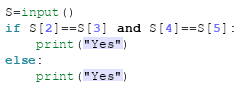<code> <loc_0><loc_0><loc_500><loc_500><_Python_>S=input()
if S[2]==S[3] and S[4]==S[5]:
    print("Yes")
else:
    print("Yes")
</code> 